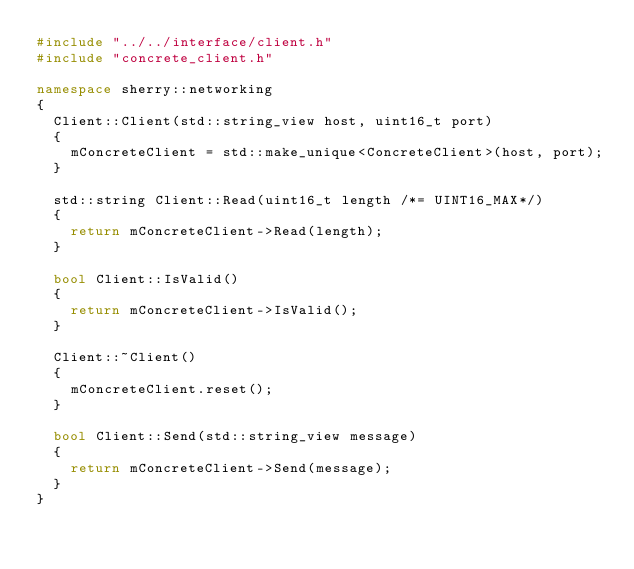<code> <loc_0><loc_0><loc_500><loc_500><_C++_>#include "../../interface/client.h"
#include "concrete_client.h"

namespace sherry::networking
{
	Client::Client(std::string_view host, uint16_t port)
	{
		mConcreteClient = std::make_unique<ConcreteClient>(host, port);
	}

	std::string Client::Read(uint16_t length /*= UINT16_MAX*/)
	{
		return mConcreteClient->Read(length);
	}

	bool Client::IsValid()
	{
		return mConcreteClient->IsValid();
	}

	Client::~Client()
	{
		mConcreteClient.reset();
	}

	bool Client::Send(std::string_view message)
	{
		return mConcreteClient->Send(message);
	}
}
</code> 